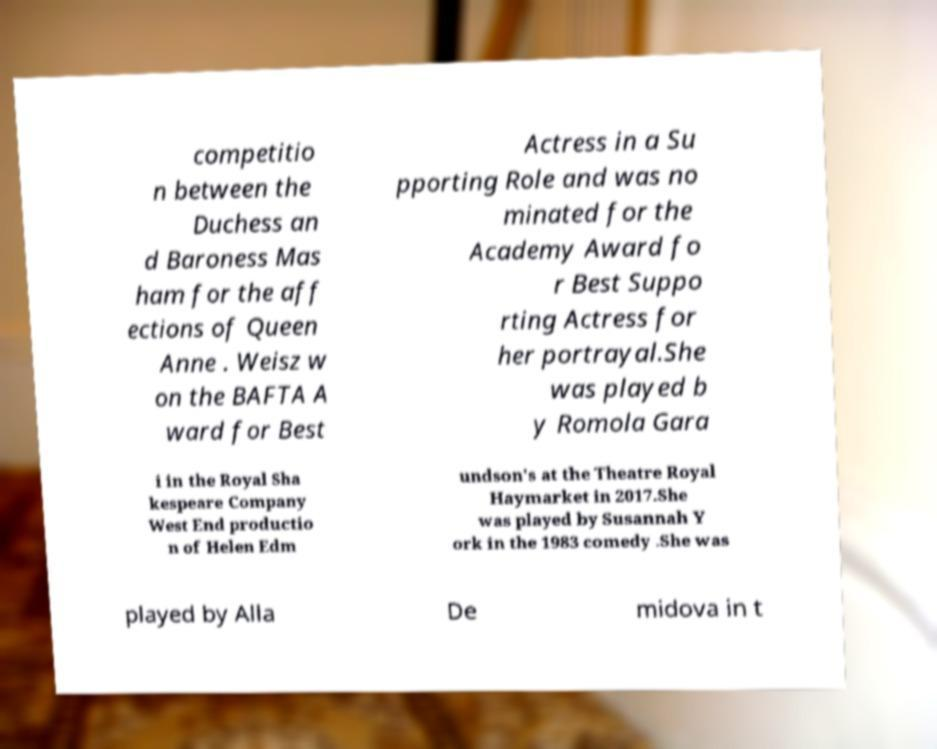Can you read and provide the text displayed in the image?This photo seems to have some interesting text. Can you extract and type it out for me? competitio n between the Duchess an d Baroness Mas ham for the aff ections of Queen Anne . Weisz w on the BAFTA A ward for Best Actress in a Su pporting Role and was no minated for the Academy Award fo r Best Suppo rting Actress for her portrayal.She was played b y Romola Gara i in the Royal Sha kespeare Company West End productio n of Helen Edm undson's at the Theatre Royal Haymarket in 2017.She was played by Susannah Y ork in the 1983 comedy .She was played by Alla De midova in t 